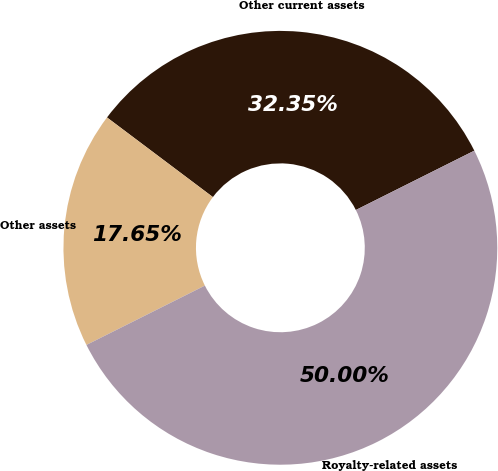Convert chart. <chart><loc_0><loc_0><loc_500><loc_500><pie_chart><fcel>Other current assets<fcel>Other assets<fcel>Royalty-related assets<nl><fcel>32.35%<fcel>17.65%<fcel>50.0%<nl></chart> 